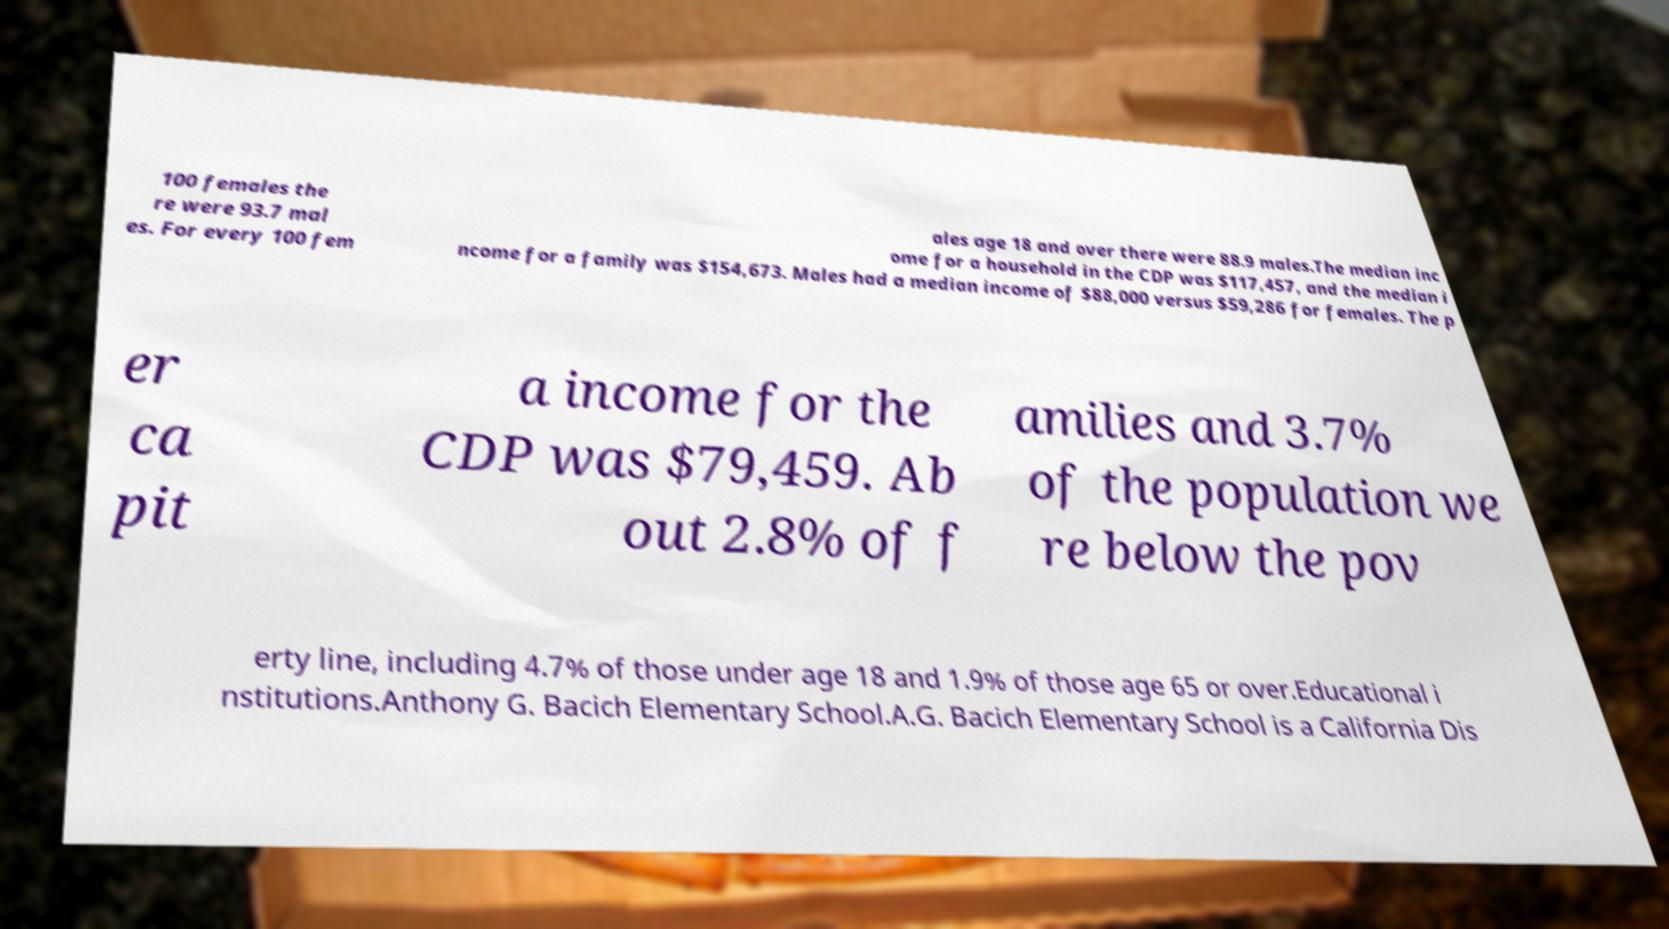Could you extract and type out the text from this image? 100 females the re were 93.7 mal es. For every 100 fem ales age 18 and over there were 88.9 males.The median inc ome for a household in the CDP was $117,457, and the median i ncome for a family was $154,673. Males had a median income of $88,000 versus $59,286 for females. The p er ca pit a income for the CDP was $79,459. Ab out 2.8% of f amilies and 3.7% of the population we re below the pov erty line, including 4.7% of those under age 18 and 1.9% of those age 65 or over.Educational i nstitutions.Anthony G. Bacich Elementary School.A.G. Bacich Elementary School is a California Dis 